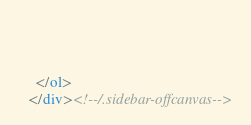Convert code to text. <code><loc_0><loc_0><loc_500><loc_500><_HTML_>    
    
    
    </ol>
  </div><!--/.sidebar-offcanvas-->
</code> 